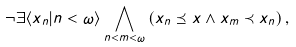Convert formula to latex. <formula><loc_0><loc_0><loc_500><loc_500>\neg \exists \langle x _ { n } | n < \omega \rangle \bigwedge _ { n < m < \omega } \left ( { x _ { n } \preceq x } \wedge { x _ { m } \prec x _ { n } } \right ) ,</formula> 